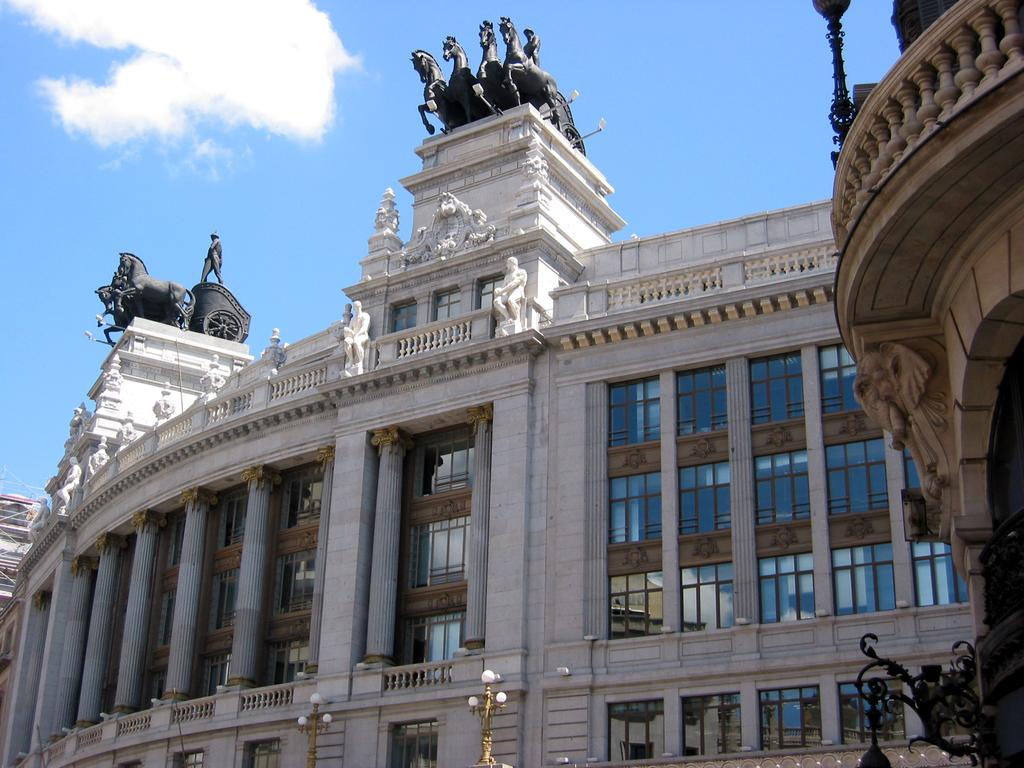What type of structure is visible in the image? There is a building in the image. What decorative elements can be seen on the building? There are statues and pillars in the image. What type of lighting is present in the image? There are street lights in the image. What architectural feature can be seen on the building? There are windows in the image. What is visible in the sky in the image? The sky is visible in the image, and there are clouds in the sky, but there is no mention of any specific objects or elements that would indicate the presence of a metal, seed, or boy in the image. What type of seed is growing in the grill in the image? There is no seed growing in the grill in the image. Can you describe the boy playing with the statues in the image? There is no boy present in the image, and therefore no such activity can be observed. 